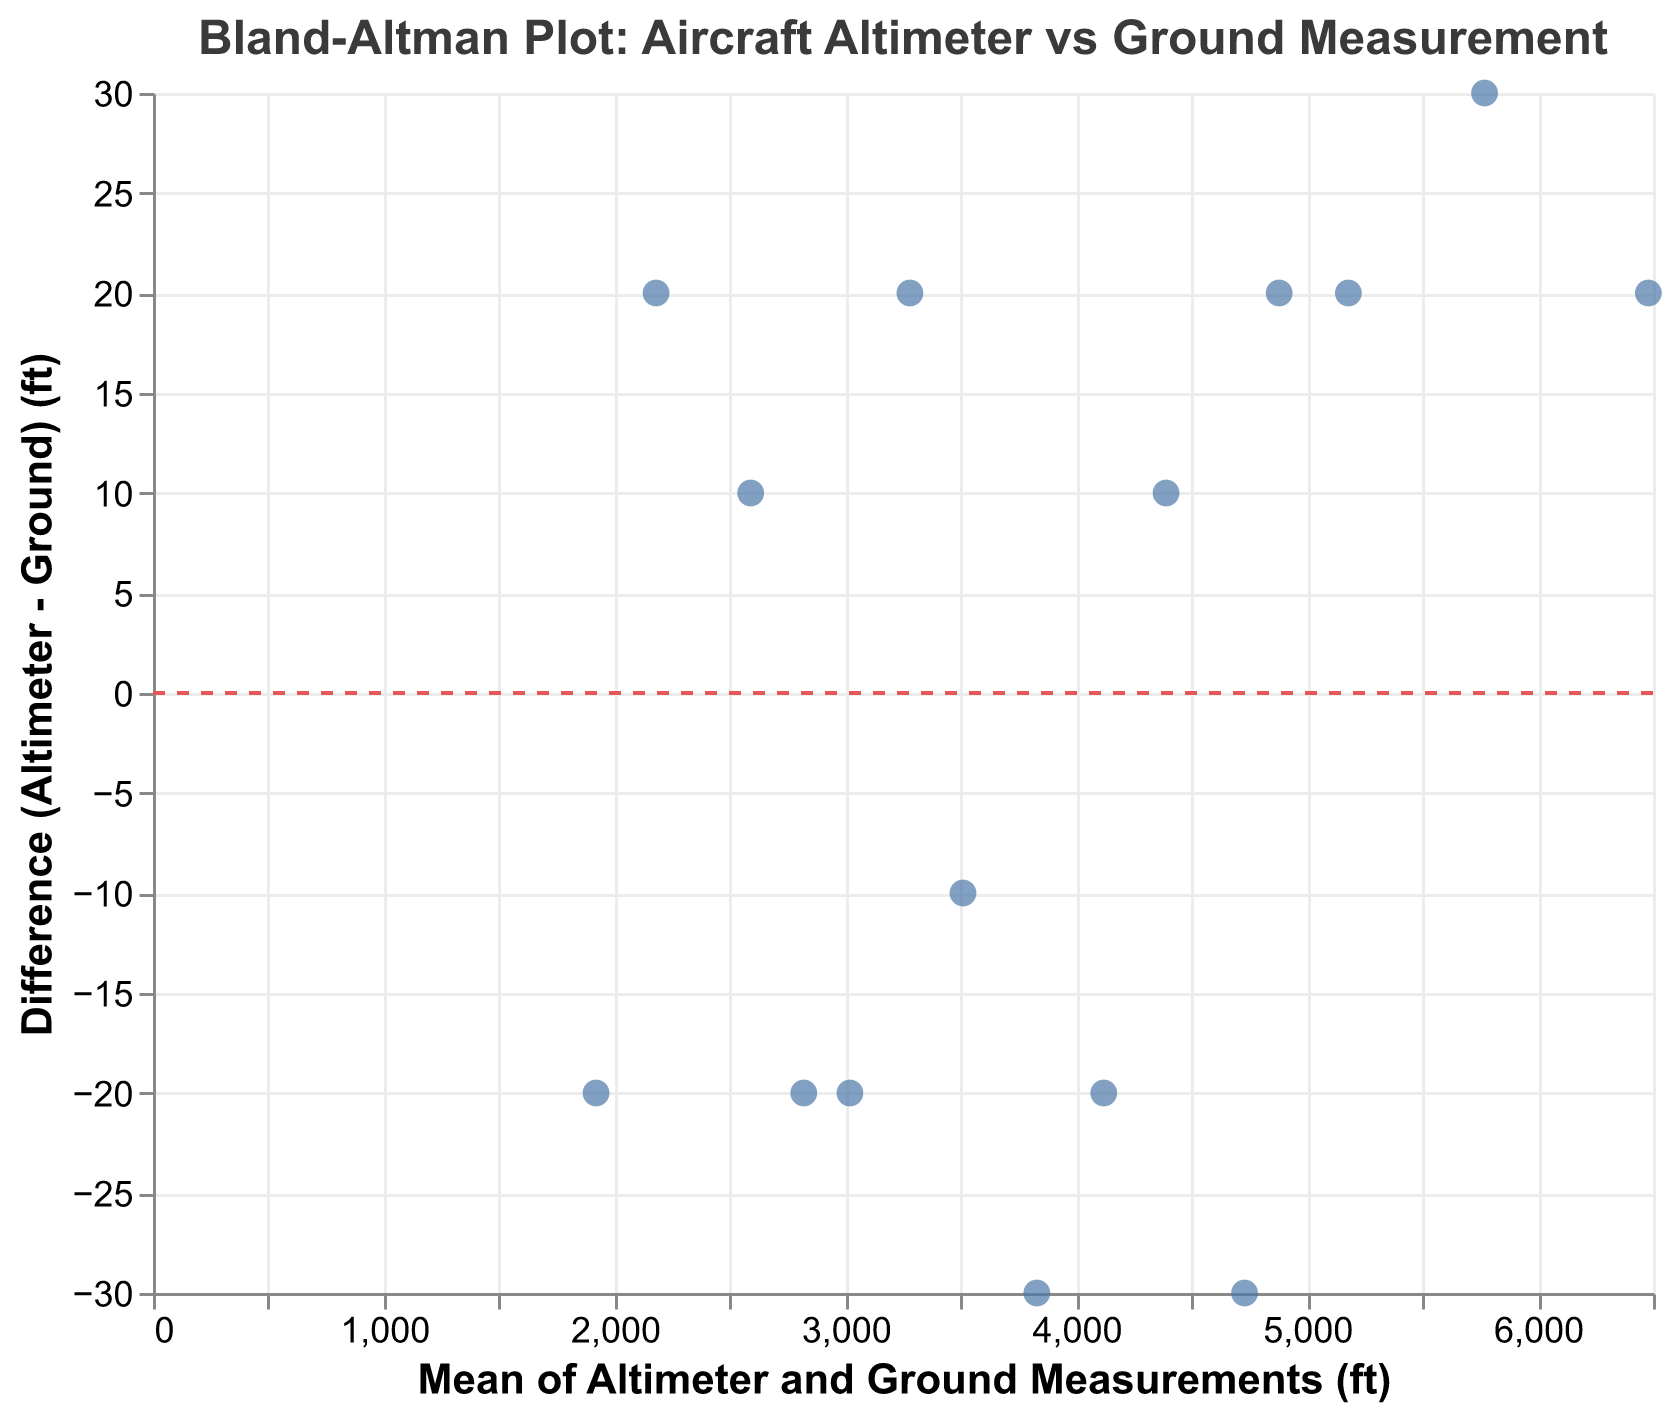What is the title of the plot? The title of the plot is at the top and reads "Bland-Altman Plot: Aircraft Altimeter vs Ground Measurement".
Answer: Bland-Altman Plot: Aircraft Altimeter vs Ground Measurement How many aircraft are represented in the plot? The number of aircraft can be counted based on the data points in the scatter plot or from the data values directly, where each row represents one aircraft. There are 15 aircraft listed in the data.
Answer: 15 Which aircraft has the largest discrepancy in measurements? The largest discrepancy is the point furthest from the y=0 line. From the data, Bell 429 has a difference of 30 feet, which is the highest absolute value of difference.
Answer: Bell 429 What is the mean of the ground measurements of all aircraft? To find the mean, sum all the ground measurements and divide by the number of aircraft: (5180 + 3830 + 2590 + 4120 + 1920 + 3280 + 2820 + 6480 + 4730 + 3510 + 5770 + 4880 + 3020 + 2180 + 4390) / 15 = 58800 / 15 = 3920 feet.
Answer: 3920 feet Which two aircrafts show identical differences in their measurements? From the data, "AgustaWestland AW109" and "Bell 407" both have a difference of -20 feet. The points for these aircraft will appear at the same y-value on the plot.
Answer: AgustaWestland AW109, Bell 407 Which aircraft has the measurement closest to the mean difference? The mean difference can be calculated by summing all differences and dividing by the number of data points: (20 - 30 + 10 - 20 - 20 + 20 - 20 + 20 - 30 - 10 + 30 + 20 - 20 + 20 + 10) / 15 = 140 / 15 ≈ 9.33 feet. Eurocopter EC135 has a difference closest to this mean value with a difference of 10 feet.
Answer: Eurocopter EC135 What is the spread of differences observed in the plot? The spread can be seen by identifying the range of differences. The maximum difference is 30 feet (Bell 429), and the minimum difference is -30 feet (Sikorsky S-76 and Eurocopter AS350). The spread is therefore 30 - (-30) = 60 feet.
Answer: 60 feet How many aircraft have a positive difference between altimeter and ground measurements? Positive differences can be counted based on points above y=0. From the data, there are 7 aircraft with positive differences (Bell 412, Eurocopter EC135, Airbus H145, Sikorsky S-92, Bell 429, Airbus H160, and MD Helicopters MD 600).
Answer: 7 Which two aircraft have the ground measurements closest to each other, and what are their values? By examining the data, the Eurocopter EC135 and MD Helicopters MD 600 have the closest ground measurements of 2590 feet and 2180 feet, respectively. The difference is 10 feet.
Answer: Eurocopter EC135 (2590 ft) and MD Helicopters MD 600 (2180 ft) 